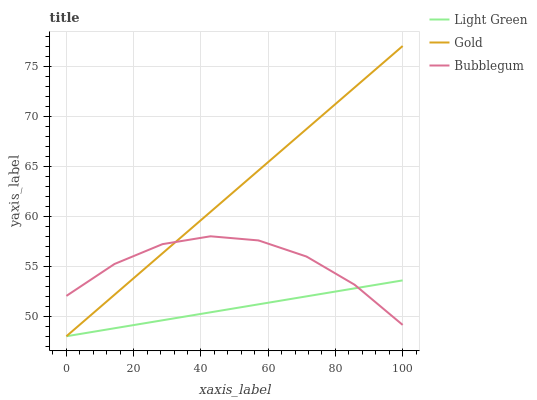Does Light Green have the minimum area under the curve?
Answer yes or no. Yes. Does Gold have the maximum area under the curve?
Answer yes or no. Yes. Does Gold have the minimum area under the curve?
Answer yes or no. No. Does Light Green have the maximum area under the curve?
Answer yes or no. No. Is Gold the smoothest?
Answer yes or no. Yes. Is Bubblegum the roughest?
Answer yes or no. Yes. Is Light Green the smoothest?
Answer yes or no. No. Is Light Green the roughest?
Answer yes or no. No. Does Gold have the lowest value?
Answer yes or no. Yes. Does Gold have the highest value?
Answer yes or no. Yes. Does Light Green have the highest value?
Answer yes or no. No. Does Light Green intersect Bubblegum?
Answer yes or no. Yes. Is Light Green less than Bubblegum?
Answer yes or no. No. Is Light Green greater than Bubblegum?
Answer yes or no. No. 